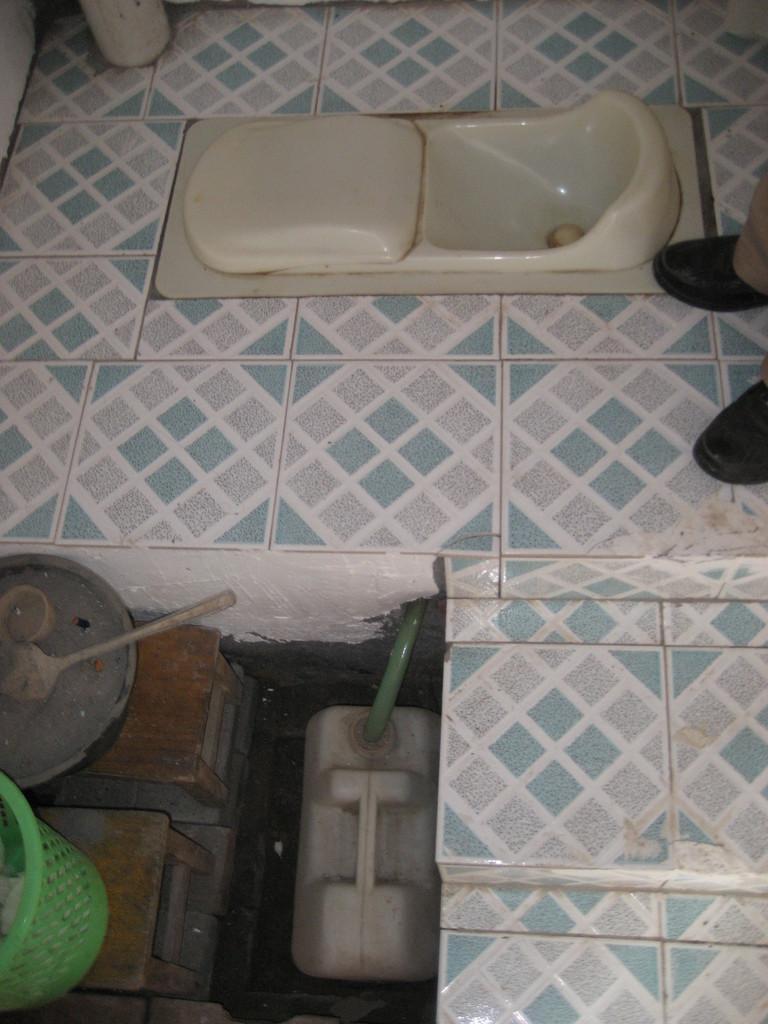Could you give a brief overview of what you see in this image? In this image, I can see a toilet seat, which is attached to a floor. At the bottom left side of the image, I can see a basket, wooden stools and few other objects. On the right side of the image, I can see the legs of a person. 